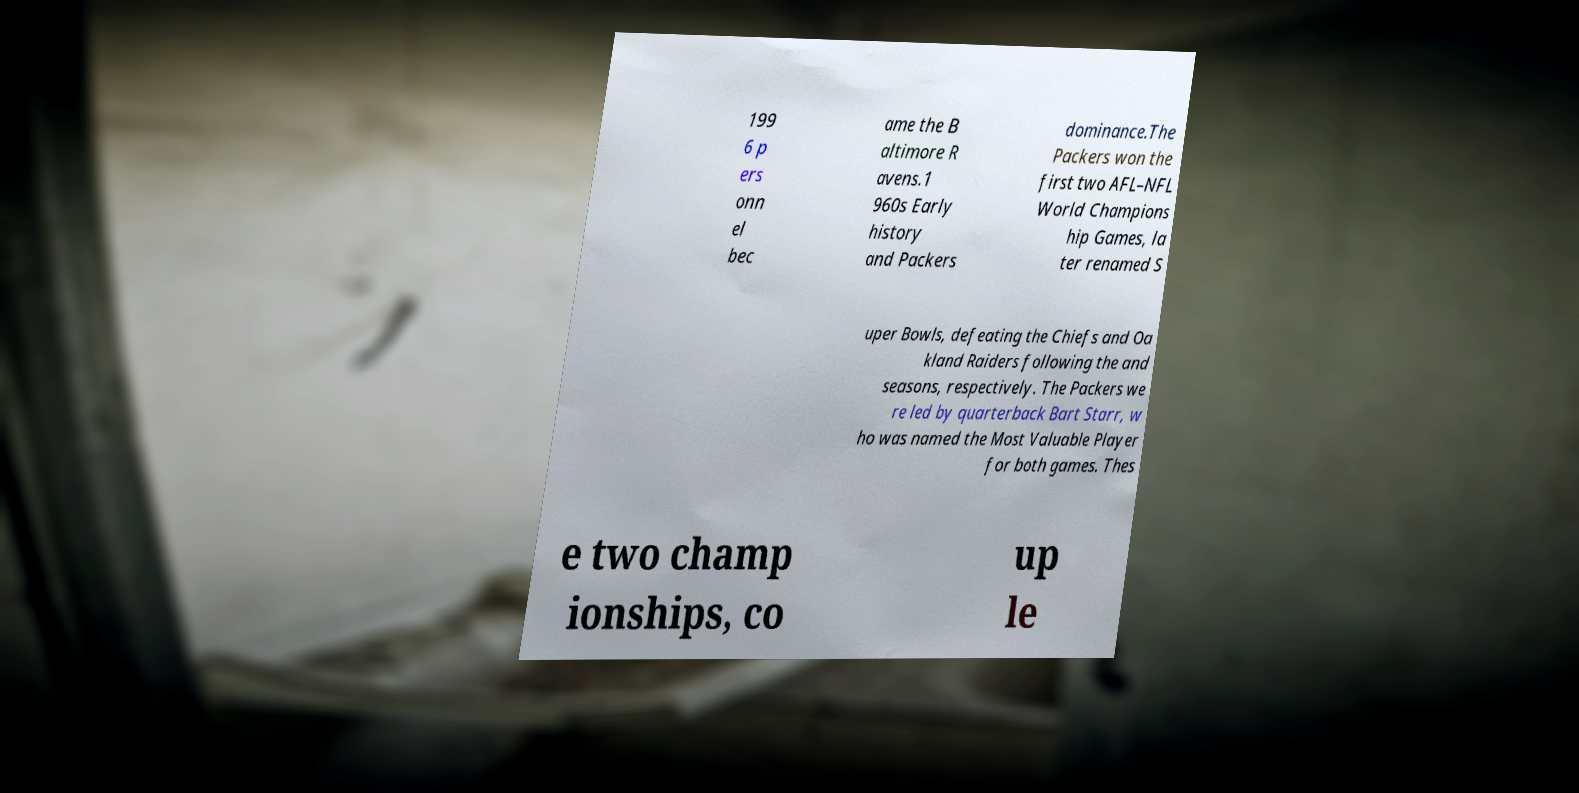I need the written content from this picture converted into text. Can you do that? 199 6 p ers onn el bec ame the B altimore R avens.1 960s Early history and Packers dominance.The Packers won the first two AFL–NFL World Champions hip Games, la ter renamed S uper Bowls, defeating the Chiefs and Oa kland Raiders following the and seasons, respectively. The Packers we re led by quarterback Bart Starr, w ho was named the Most Valuable Player for both games. Thes e two champ ionships, co up le 